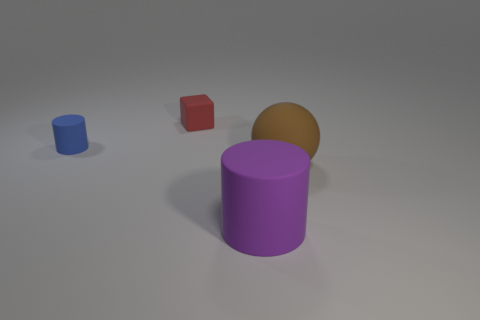How many things are rubber objects that are left of the big sphere or large matte spheres?
Provide a short and direct response. 4. Does the purple thing have the same shape as the big rubber thing right of the purple thing?
Keep it short and to the point. No. What number of rubber objects are in front of the blue rubber cylinder and behind the blue object?
Provide a succinct answer. 0. There is a large purple object that is the same shape as the small blue rubber thing; what is it made of?
Ensure brevity in your answer.  Rubber. What size is the cylinder left of the cylinder right of the small cube?
Your answer should be compact. Small. Is there a cyan rubber block?
Your answer should be very brief. No. There is a object that is to the right of the tiny blue matte thing and behind the ball; what is its material?
Your response must be concise. Rubber. Is the number of matte cubes on the right side of the rubber sphere greater than the number of small red matte things behind the cube?
Ensure brevity in your answer.  No. Is there a blue rubber cylinder of the same size as the brown rubber thing?
Offer a very short reply. No. There is a matte thing left of the small thing that is behind the rubber cylinder that is behind the big brown object; what size is it?
Provide a succinct answer. Small. 